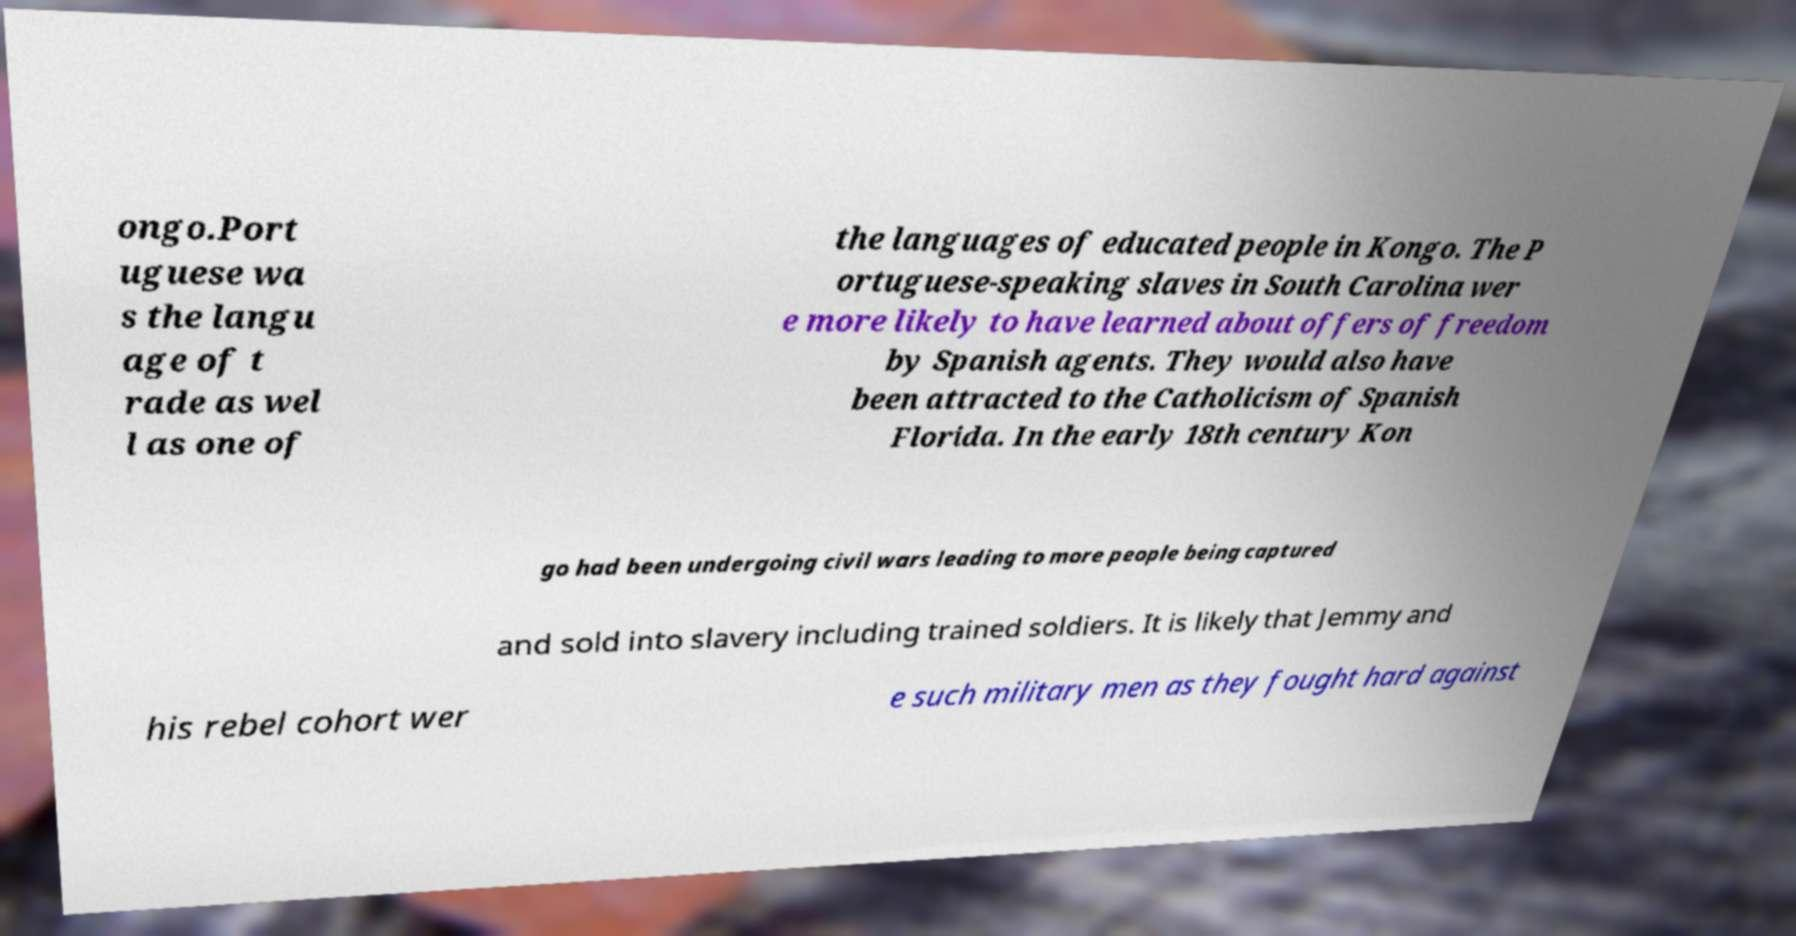Can you accurately transcribe the text from the provided image for me? ongo.Port uguese wa s the langu age of t rade as wel l as one of the languages of educated people in Kongo. The P ortuguese-speaking slaves in South Carolina wer e more likely to have learned about offers of freedom by Spanish agents. They would also have been attracted to the Catholicism of Spanish Florida. In the early 18th century Kon go had been undergoing civil wars leading to more people being captured and sold into slavery including trained soldiers. It is likely that Jemmy and his rebel cohort wer e such military men as they fought hard against 